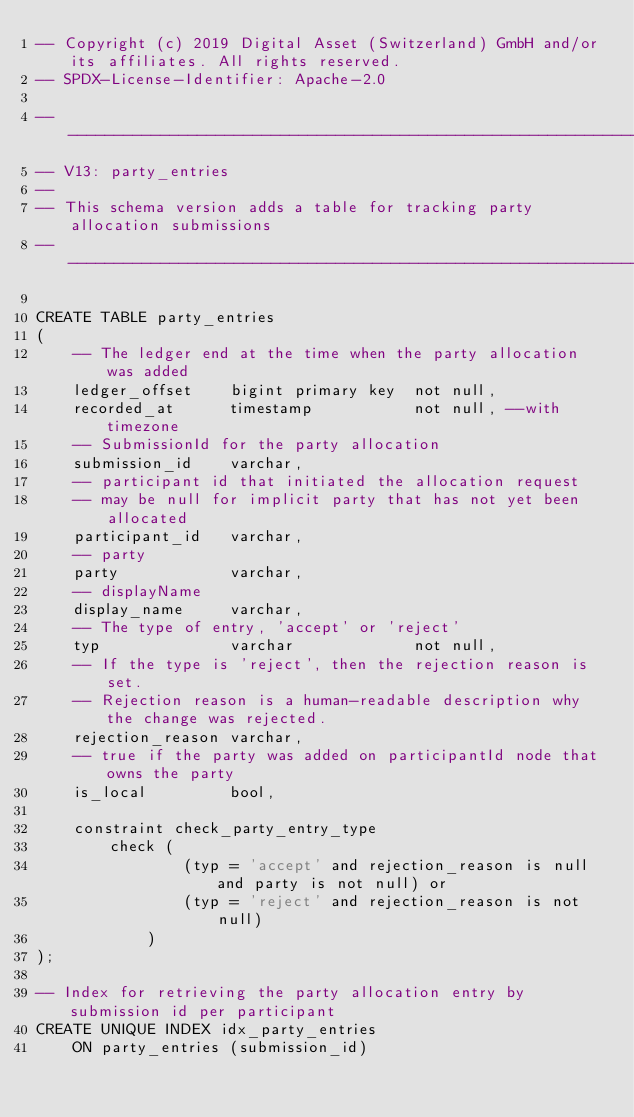<code> <loc_0><loc_0><loc_500><loc_500><_SQL_>-- Copyright (c) 2019 Digital Asset (Switzerland) GmbH and/or its affiliates. All rights reserved.
-- SPDX-License-Identifier: Apache-2.0

---------------------------------------------------------------------------------------------------
-- V13: party_entries
--
-- This schema version adds a table for tracking party allocation submissions
---------------------------------------------------------------------------------------------------

CREATE TABLE party_entries
(
    -- The ledger end at the time when the party allocation was added
    ledger_offset    bigint primary key  not null,
    recorded_at      timestamp           not null, --with timezone
    -- SubmissionId for the party allocation
    submission_id    varchar,
    -- participant id that initiated the allocation request
    -- may be null for implicit party that has not yet been allocated
    participant_id   varchar,
    -- party
    party            varchar,
    -- displayName
    display_name     varchar,
    -- The type of entry, 'accept' or 'reject'
    typ              varchar             not null,
    -- If the type is 'reject', then the rejection reason is set.
    -- Rejection reason is a human-readable description why the change was rejected.
    rejection_reason varchar,
    -- true if the party was added on participantId node that owns the party
    is_local         bool,

    constraint check_party_entry_type
        check (
                (typ = 'accept' and rejection_reason is null and party is not null) or
                (typ = 'reject' and rejection_reason is not null)
            )
);

-- Index for retrieving the party allocation entry by submission id per participant
CREATE UNIQUE INDEX idx_party_entries
    ON party_entries (submission_id)</code> 